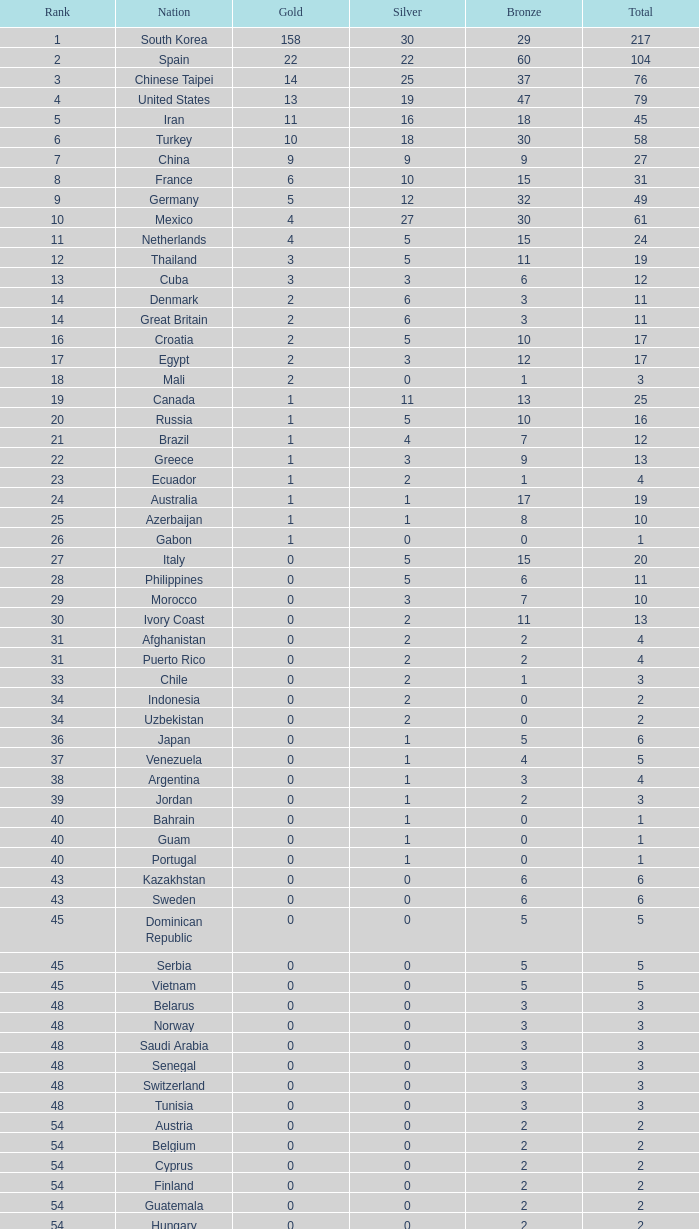What is the Total medals for the Nation ranking 33 with more than 1 Bronze? None. 